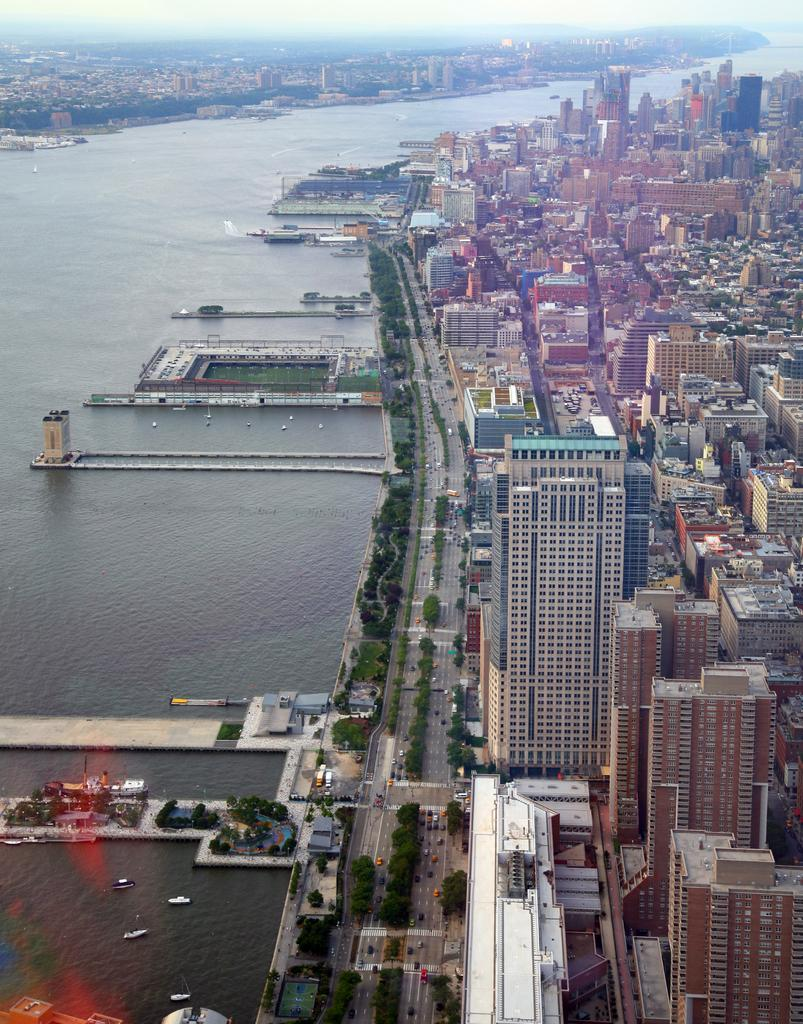What type of view is shown in the image? The image is an aerial view. What can be seen on the ground in the image? There are roads and trees visible in the image. What natural feature is present in the image? There is a sea in the image. What type of structures can be seen in the image? There are buildings in the image. What is visible above the ground in the image? The sky is visible in the image. Where is the advertisement for the vein clinic located in the image? There is no advertisement for a vein clinic present in the image. What type of rail system can be seen connecting the buildings in the image? There is no rail system visible in the image; it only shows roads and buildings. 